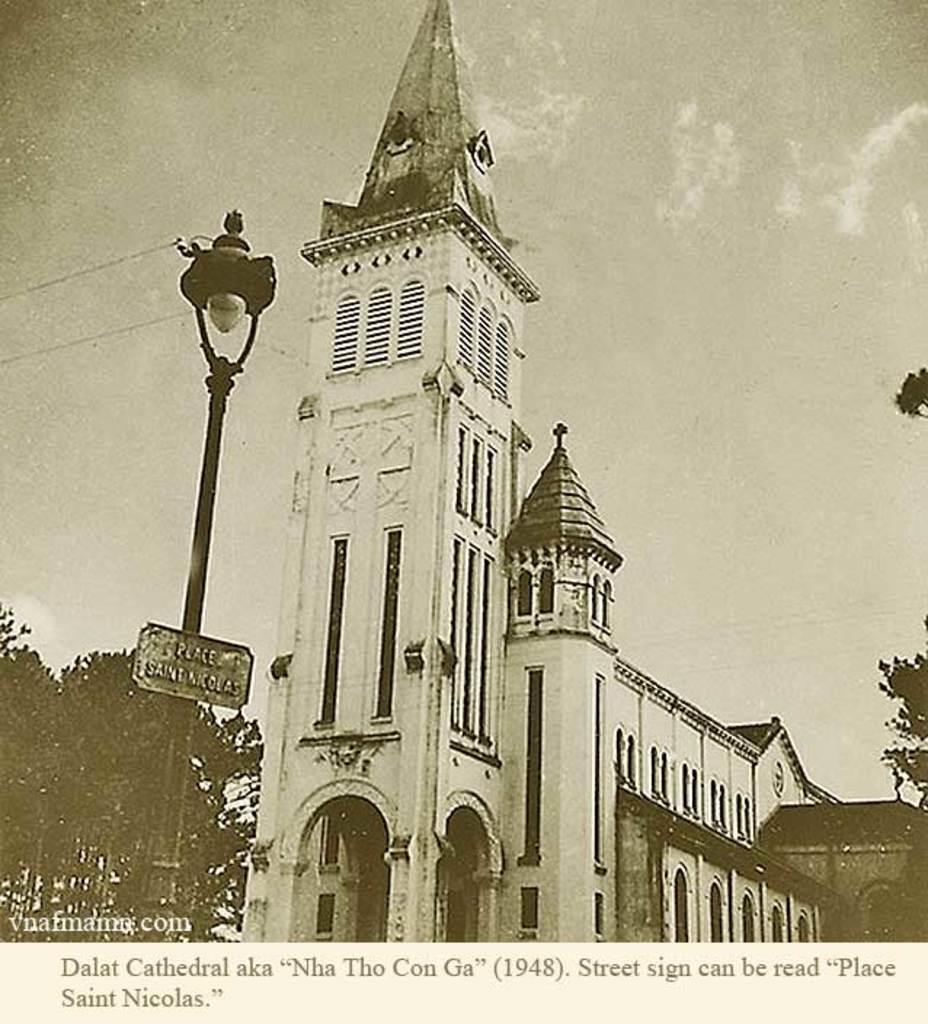How would you summarize this image in a sentence or two? This is a black and white picture. In this picture, we see a building in white color. On the right side, we see the trees. In front of the picture, we see a light pole and a board with some text written. On the left side, we see the trees. In the background, we see the sky. This picture might be a poster. 